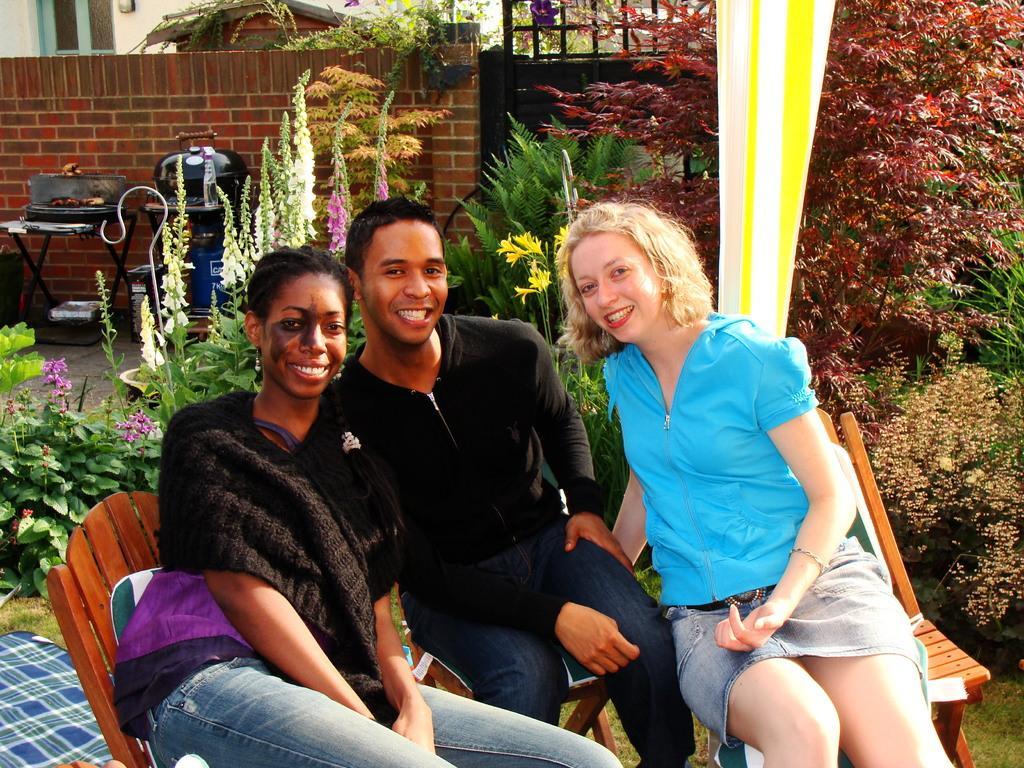In one or two sentences, can you explain what this image depicts? In this image there are people sitting on chairs, in the background there are plants, behind the plants there is a wall, near the wall there is a grill on stand, behind the wall there is a building. 